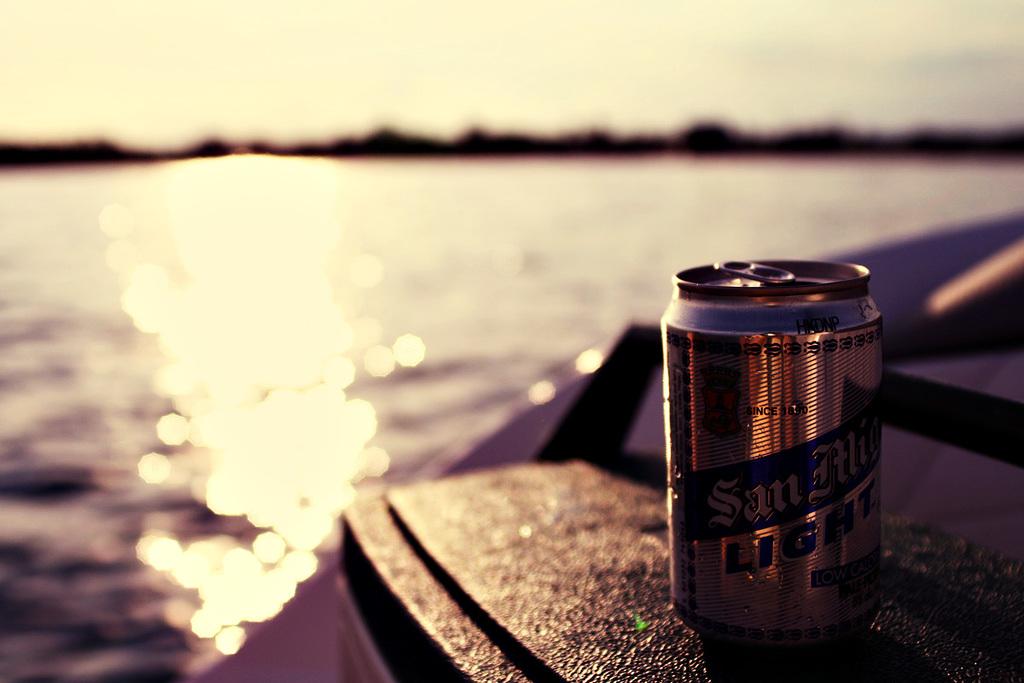What kind of beer is this?
Provide a succinct answer. Unanswerable. 